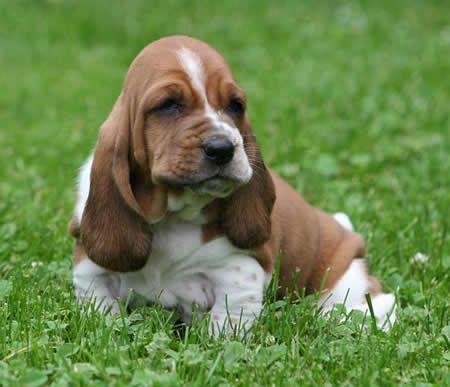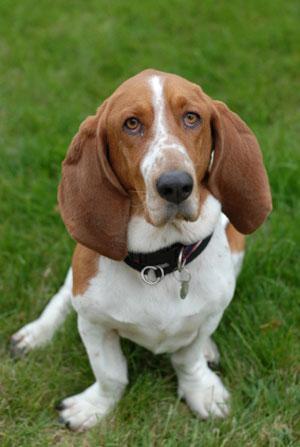The first image is the image on the left, the second image is the image on the right. For the images displayed, is the sentence "the dog appears to be moving in one of the images" factually correct? Answer yes or no. No. The first image is the image on the left, the second image is the image on the right. For the images shown, is this caption "A floppy eared dog is moving forward across the grass in one image." true? Answer yes or no. No. 